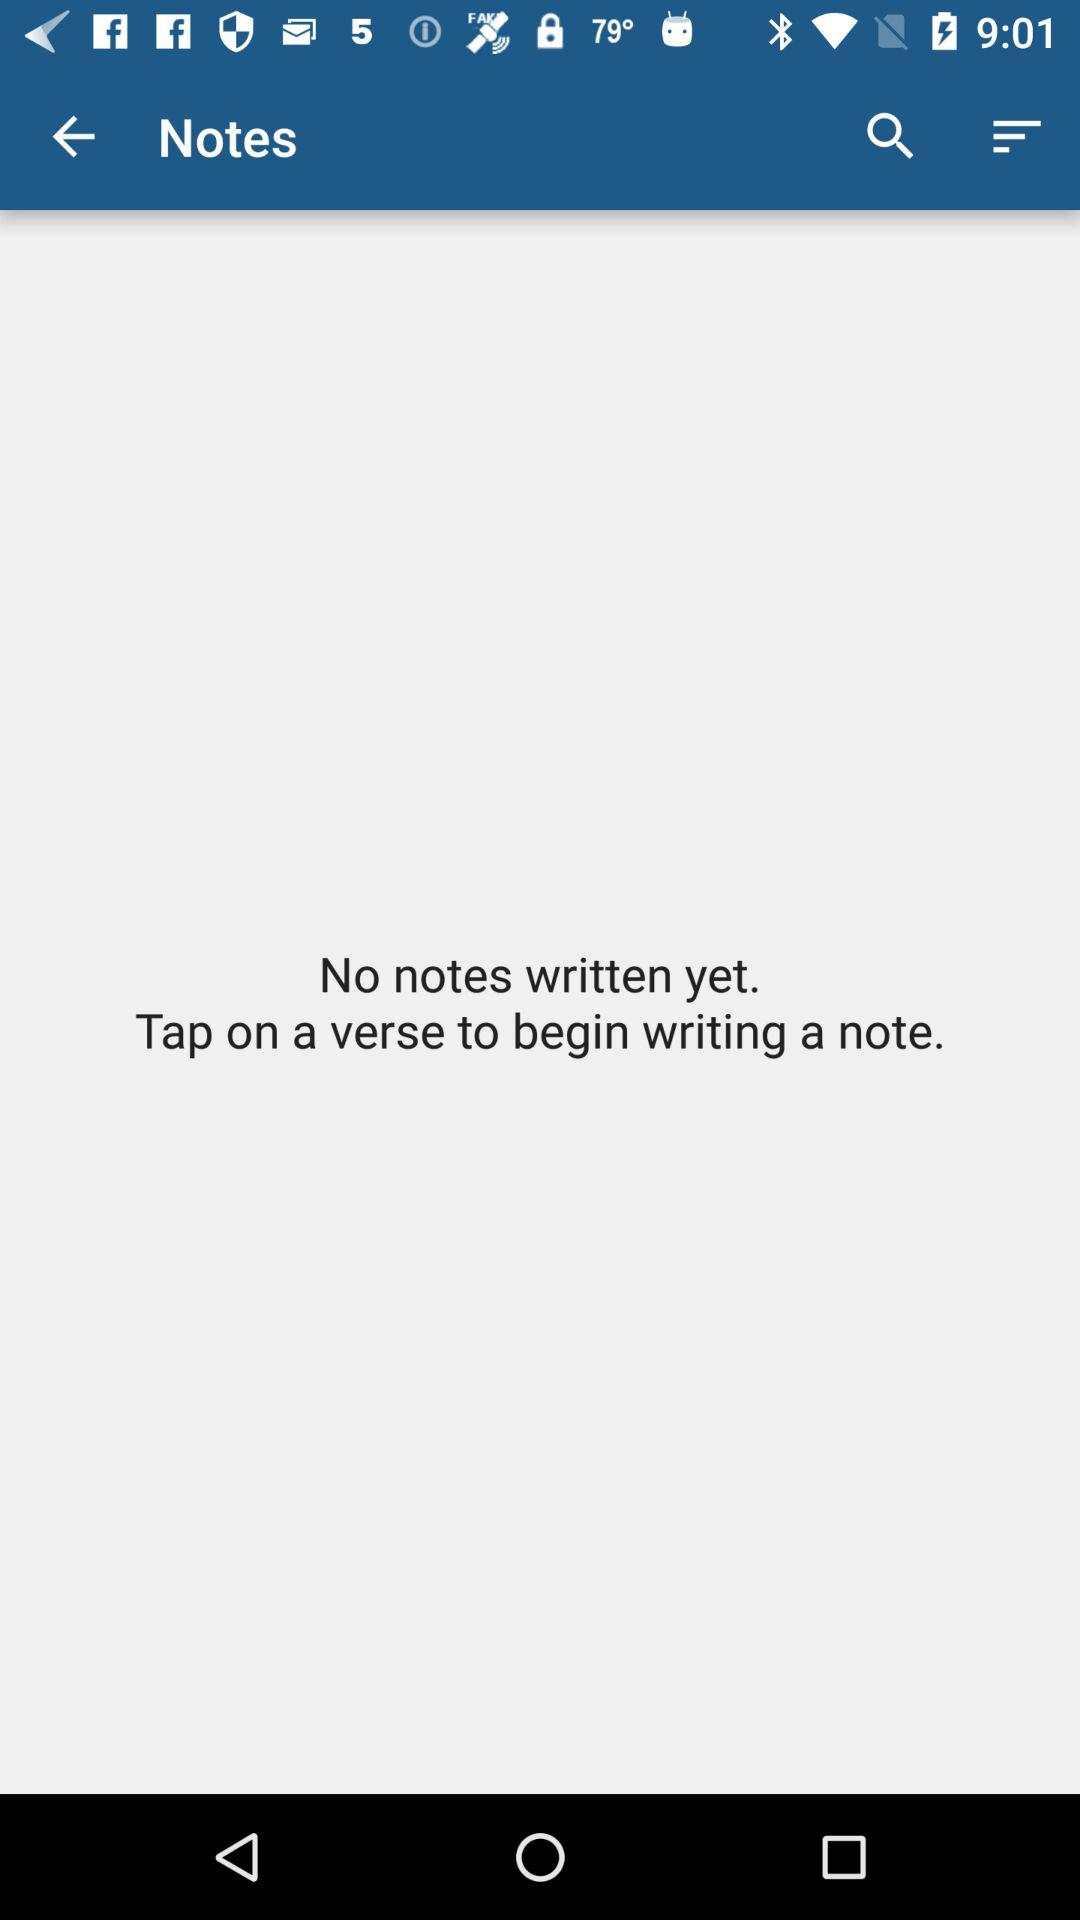How many written notes are there right now? There are no notes written yet. 